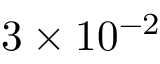<formula> <loc_0><loc_0><loc_500><loc_500>3 \times 1 0 ^ { - 2 }</formula> 